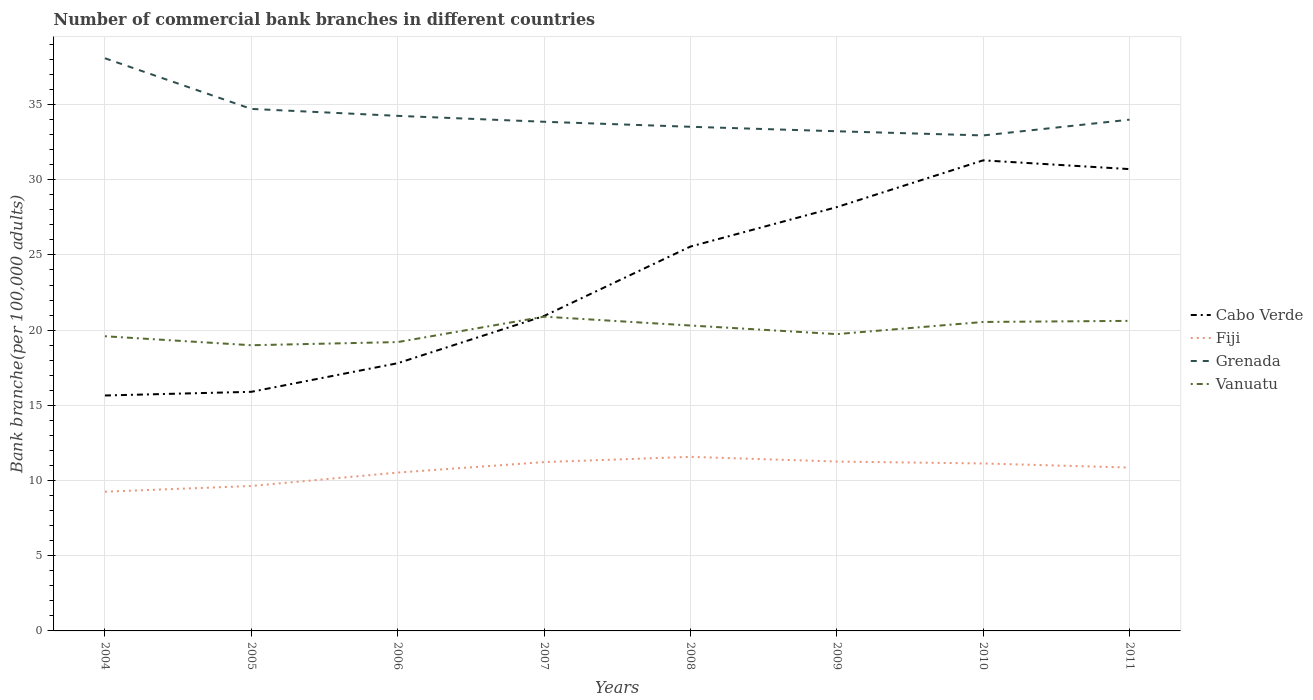How many different coloured lines are there?
Offer a very short reply. 4. Does the line corresponding to Grenada intersect with the line corresponding to Fiji?
Provide a short and direct response. No. Is the number of lines equal to the number of legend labels?
Provide a short and direct response. Yes. Across all years, what is the maximum number of commercial bank branches in Vanuatu?
Offer a terse response. 19. In which year was the number of commercial bank branches in Vanuatu maximum?
Your answer should be very brief. 2005. What is the total number of commercial bank branches in Cabo Verde in the graph?
Offer a terse response. -12.28. What is the difference between the highest and the second highest number of commercial bank branches in Cabo Verde?
Your response must be concise. 15.63. What is the difference between the highest and the lowest number of commercial bank branches in Fiji?
Keep it short and to the point. 5. Is the number of commercial bank branches in Grenada strictly greater than the number of commercial bank branches in Vanuatu over the years?
Ensure brevity in your answer.  No. How many years are there in the graph?
Provide a short and direct response. 8. Are the values on the major ticks of Y-axis written in scientific E-notation?
Your response must be concise. No. Does the graph contain any zero values?
Ensure brevity in your answer.  No. How many legend labels are there?
Offer a very short reply. 4. How are the legend labels stacked?
Make the answer very short. Vertical. What is the title of the graph?
Keep it short and to the point. Number of commercial bank branches in different countries. What is the label or title of the Y-axis?
Keep it short and to the point. Bank branche(per 100,0 adults). What is the Bank branche(per 100,000 adults) in Cabo Verde in 2004?
Provide a succinct answer. 15.65. What is the Bank branche(per 100,000 adults) in Fiji in 2004?
Your answer should be very brief. 9.26. What is the Bank branche(per 100,000 adults) in Grenada in 2004?
Ensure brevity in your answer.  38.08. What is the Bank branche(per 100,000 adults) of Vanuatu in 2004?
Offer a very short reply. 19.59. What is the Bank branche(per 100,000 adults) in Cabo Verde in 2005?
Offer a terse response. 15.9. What is the Bank branche(per 100,000 adults) in Fiji in 2005?
Offer a terse response. 9.64. What is the Bank branche(per 100,000 adults) in Grenada in 2005?
Your answer should be compact. 34.71. What is the Bank branche(per 100,000 adults) in Vanuatu in 2005?
Provide a short and direct response. 19. What is the Bank branche(per 100,000 adults) of Cabo Verde in 2006?
Give a very brief answer. 17.8. What is the Bank branche(per 100,000 adults) of Fiji in 2006?
Ensure brevity in your answer.  10.53. What is the Bank branche(per 100,000 adults) of Grenada in 2006?
Keep it short and to the point. 34.25. What is the Bank branche(per 100,000 adults) in Vanuatu in 2006?
Offer a very short reply. 19.21. What is the Bank branche(per 100,000 adults) of Cabo Verde in 2007?
Provide a short and direct response. 20.94. What is the Bank branche(per 100,000 adults) of Fiji in 2007?
Offer a terse response. 11.23. What is the Bank branche(per 100,000 adults) in Grenada in 2007?
Offer a very short reply. 33.86. What is the Bank branche(per 100,000 adults) in Vanuatu in 2007?
Your answer should be compact. 20.9. What is the Bank branche(per 100,000 adults) in Cabo Verde in 2008?
Offer a terse response. 25.56. What is the Bank branche(per 100,000 adults) in Fiji in 2008?
Offer a very short reply. 11.57. What is the Bank branche(per 100,000 adults) in Grenada in 2008?
Make the answer very short. 33.52. What is the Bank branche(per 100,000 adults) of Vanuatu in 2008?
Make the answer very short. 20.31. What is the Bank branche(per 100,000 adults) in Cabo Verde in 2009?
Provide a succinct answer. 28.18. What is the Bank branche(per 100,000 adults) of Fiji in 2009?
Provide a succinct answer. 11.26. What is the Bank branche(per 100,000 adults) of Grenada in 2009?
Offer a terse response. 33.22. What is the Bank branche(per 100,000 adults) of Vanuatu in 2009?
Offer a very short reply. 19.74. What is the Bank branche(per 100,000 adults) in Cabo Verde in 2010?
Make the answer very short. 31.29. What is the Bank branche(per 100,000 adults) of Fiji in 2010?
Make the answer very short. 11.14. What is the Bank branche(per 100,000 adults) in Grenada in 2010?
Your response must be concise. 32.95. What is the Bank branche(per 100,000 adults) of Vanuatu in 2010?
Make the answer very short. 20.54. What is the Bank branche(per 100,000 adults) in Cabo Verde in 2011?
Your answer should be very brief. 30.71. What is the Bank branche(per 100,000 adults) of Fiji in 2011?
Provide a succinct answer. 10.86. What is the Bank branche(per 100,000 adults) in Grenada in 2011?
Keep it short and to the point. 34. What is the Bank branche(per 100,000 adults) of Vanuatu in 2011?
Ensure brevity in your answer.  20.62. Across all years, what is the maximum Bank branche(per 100,000 adults) in Cabo Verde?
Make the answer very short. 31.29. Across all years, what is the maximum Bank branche(per 100,000 adults) in Fiji?
Provide a short and direct response. 11.57. Across all years, what is the maximum Bank branche(per 100,000 adults) of Grenada?
Your response must be concise. 38.08. Across all years, what is the maximum Bank branche(per 100,000 adults) of Vanuatu?
Ensure brevity in your answer.  20.9. Across all years, what is the minimum Bank branche(per 100,000 adults) in Cabo Verde?
Your answer should be very brief. 15.65. Across all years, what is the minimum Bank branche(per 100,000 adults) of Fiji?
Your response must be concise. 9.26. Across all years, what is the minimum Bank branche(per 100,000 adults) of Grenada?
Provide a succinct answer. 32.95. Across all years, what is the minimum Bank branche(per 100,000 adults) in Vanuatu?
Provide a succinct answer. 19. What is the total Bank branche(per 100,000 adults) of Cabo Verde in the graph?
Ensure brevity in your answer.  186.03. What is the total Bank branche(per 100,000 adults) in Fiji in the graph?
Your answer should be compact. 85.48. What is the total Bank branche(per 100,000 adults) in Grenada in the graph?
Ensure brevity in your answer.  274.58. What is the total Bank branche(per 100,000 adults) in Vanuatu in the graph?
Offer a terse response. 159.9. What is the difference between the Bank branche(per 100,000 adults) of Cabo Verde in 2004 and that in 2005?
Offer a very short reply. -0.24. What is the difference between the Bank branche(per 100,000 adults) of Fiji in 2004 and that in 2005?
Your answer should be very brief. -0.38. What is the difference between the Bank branche(per 100,000 adults) in Grenada in 2004 and that in 2005?
Provide a short and direct response. 3.37. What is the difference between the Bank branche(per 100,000 adults) in Vanuatu in 2004 and that in 2005?
Offer a terse response. 0.6. What is the difference between the Bank branche(per 100,000 adults) in Cabo Verde in 2004 and that in 2006?
Ensure brevity in your answer.  -2.15. What is the difference between the Bank branche(per 100,000 adults) of Fiji in 2004 and that in 2006?
Make the answer very short. -1.27. What is the difference between the Bank branche(per 100,000 adults) of Grenada in 2004 and that in 2006?
Ensure brevity in your answer.  3.83. What is the difference between the Bank branche(per 100,000 adults) of Vanuatu in 2004 and that in 2006?
Your response must be concise. 0.39. What is the difference between the Bank branche(per 100,000 adults) of Cabo Verde in 2004 and that in 2007?
Keep it short and to the point. -5.29. What is the difference between the Bank branche(per 100,000 adults) of Fiji in 2004 and that in 2007?
Give a very brief answer. -1.97. What is the difference between the Bank branche(per 100,000 adults) in Grenada in 2004 and that in 2007?
Offer a very short reply. 4.22. What is the difference between the Bank branche(per 100,000 adults) of Vanuatu in 2004 and that in 2007?
Make the answer very short. -1.3. What is the difference between the Bank branche(per 100,000 adults) of Cabo Verde in 2004 and that in 2008?
Ensure brevity in your answer.  -9.9. What is the difference between the Bank branche(per 100,000 adults) in Fiji in 2004 and that in 2008?
Make the answer very short. -2.32. What is the difference between the Bank branche(per 100,000 adults) of Grenada in 2004 and that in 2008?
Offer a terse response. 4.56. What is the difference between the Bank branche(per 100,000 adults) in Vanuatu in 2004 and that in 2008?
Give a very brief answer. -0.71. What is the difference between the Bank branche(per 100,000 adults) in Cabo Verde in 2004 and that in 2009?
Offer a very short reply. -12.53. What is the difference between the Bank branche(per 100,000 adults) of Fiji in 2004 and that in 2009?
Give a very brief answer. -2.01. What is the difference between the Bank branche(per 100,000 adults) of Grenada in 2004 and that in 2009?
Your answer should be compact. 4.85. What is the difference between the Bank branche(per 100,000 adults) of Vanuatu in 2004 and that in 2009?
Your answer should be very brief. -0.14. What is the difference between the Bank branche(per 100,000 adults) of Cabo Verde in 2004 and that in 2010?
Offer a terse response. -15.63. What is the difference between the Bank branche(per 100,000 adults) in Fiji in 2004 and that in 2010?
Ensure brevity in your answer.  -1.88. What is the difference between the Bank branche(per 100,000 adults) of Grenada in 2004 and that in 2010?
Offer a very short reply. 5.13. What is the difference between the Bank branche(per 100,000 adults) in Vanuatu in 2004 and that in 2010?
Offer a very short reply. -0.95. What is the difference between the Bank branche(per 100,000 adults) of Cabo Verde in 2004 and that in 2011?
Your response must be concise. -15.05. What is the difference between the Bank branche(per 100,000 adults) in Fiji in 2004 and that in 2011?
Provide a short and direct response. -1.61. What is the difference between the Bank branche(per 100,000 adults) of Grenada in 2004 and that in 2011?
Your response must be concise. 4.08. What is the difference between the Bank branche(per 100,000 adults) of Vanuatu in 2004 and that in 2011?
Your answer should be compact. -1.02. What is the difference between the Bank branche(per 100,000 adults) of Cabo Verde in 2005 and that in 2006?
Keep it short and to the point. -1.9. What is the difference between the Bank branche(per 100,000 adults) of Fiji in 2005 and that in 2006?
Ensure brevity in your answer.  -0.89. What is the difference between the Bank branche(per 100,000 adults) in Grenada in 2005 and that in 2006?
Give a very brief answer. 0.46. What is the difference between the Bank branche(per 100,000 adults) of Vanuatu in 2005 and that in 2006?
Offer a terse response. -0.21. What is the difference between the Bank branche(per 100,000 adults) of Cabo Verde in 2005 and that in 2007?
Provide a succinct answer. -5.04. What is the difference between the Bank branche(per 100,000 adults) of Fiji in 2005 and that in 2007?
Offer a terse response. -1.59. What is the difference between the Bank branche(per 100,000 adults) in Grenada in 2005 and that in 2007?
Make the answer very short. 0.85. What is the difference between the Bank branche(per 100,000 adults) in Vanuatu in 2005 and that in 2007?
Offer a terse response. -1.9. What is the difference between the Bank branche(per 100,000 adults) of Cabo Verde in 2005 and that in 2008?
Make the answer very short. -9.66. What is the difference between the Bank branche(per 100,000 adults) in Fiji in 2005 and that in 2008?
Ensure brevity in your answer.  -1.94. What is the difference between the Bank branche(per 100,000 adults) of Grenada in 2005 and that in 2008?
Give a very brief answer. 1.19. What is the difference between the Bank branche(per 100,000 adults) of Vanuatu in 2005 and that in 2008?
Make the answer very short. -1.31. What is the difference between the Bank branche(per 100,000 adults) of Cabo Verde in 2005 and that in 2009?
Your answer should be very brief. -12.28. What is the difference between the Bank branche(per 100,000 adults) in Fiji in 2005 and that in 2009?
Your answer should be compact. -1.62. What is the difference between the Bank branche(per 100,000 adults) of Grenada in 2005 and that in 2009?
Your answer should be very brief. 1.49. What is the difference between the Bank branche(per 100,000 adults) in Vanuatu in 2005 and that in 2009?
Your answer should be very brief. -0.74. What is the difference between the Bank branche(per 100,000 adults) of Cabo Verde in 2005 and that in 2010?
Offer a very short reply. -15.39. What is the difference between the Bank branche(per 100,000 adults) in Fiji in 2005 and that in 2010?
Your answer should be very brief. -1.5. What is the difference between the Bank branche(per 100,000 adults) of Grenada in 2005 and that in 2010?
Offer a terse response. 1.76. What is the difference between the Bank branche(per 100,000 adults) of Vanuatu in 2005 and that in 2010?
Provide a succinct answer. -1.55. What is the difference between the Bank branche(per 100,000 adults) of Cabo Verde in 2005 and that in 2011?
Give a very brief answer. -14.81. What is the difference between the Bank branche(per 100,000 adults) of Fiji in 2005 and that in 2011?
Your answer should be very brief. -1.22. What is the difference between the Bank branche(per 100,000 adults) in Grenada in 2005 and that in 2011?
Make the answer very short. 0.71. What is the difference between the Bank branche(per 100,000 adults) of Vanuatu in 2005 and that in 2011?
Your answer should be very brief. -1.62. What is the difference between the Bank branche(per 100,000 adults) in Cabo Verde in 2006 and that in 2007?
Keep it short and to the point. -3.14. What is the difference between the Bank branche(per 100,000 adults) of Fiji in 2006 and that in 2007?
Your answer should be compact. -0.7. What is the difference between the Bank branche(per 100,000 adults) of Grenada in 2006 and that in 2007?
Keep it short and to the point. 0.39. What is the difference between the Bank branche(per 100,000 adults) in Vanuatu in 2006 and that in 2007?
Offer a terse response. -1.69. What is the difference between the Bank branche(per 100,000 adults) in Cabo Verde in 2006 and that in 2008?
Offer a very short reply. -7.76. What is the difference between the Bank branche(per 100,000 adults) in Fiji in 2006 and that in 2008?
Provide a short and direct response. -1.05. What is the difference between the Bank branche(per 100,000 adults) of Grenada in 2006 and that in 2008?
Your response must be concise. 0.73. What is the difference between the Bank branche(per 100,000 adults) of Vanuatu in 2006 and that in 2008?
Your response must be concise. -1.1. What is the difference between the Bank branche(per 100,000 adults) of Cabo Verde in 2006 and that in 2009?
Provide a succinct answer. -10.38. What is the difference between the Bank branche(per 100,000 adults) in Fiji in 2006 and that in 2009?
Ensure brevity in your answer.  -0.73. What is the difference between the Bank branche(per 100,000 adults) in Grenada in 2006 and that in 2009?
Your answer should be very brief. 1.02. What is the difference between the Bank branche(per 100,000 adults) of Vanuatu in 2006 and that in 2009?
Provide a short and direct response. -0.53. What is the difference between the Bank branche(per 100,000 adults) in Cabo Verde in 2006 and that in 2010?
Provide a short and direct response. -13.49. What is the difference between the Bank branche(per 100,000 adults) in Fiji in 2006 and that in 2010?
Keep it short and to the point. -0.61. What is the difference between the Bank branche(per 100,000 adults) of Grenada in 2006 and that in 2010?
Offer a terse response. 1.3. What is the difference between the Bank branche(per 100,000 adults) of Vanuatu in 2006 and that in 2010?
Your response must be concise. -1.34. What is the difference between the Bank branche(per 100,000 adults) in Cabo Verde in 2006 and that in 2011?
Give a very brief answer. -12.91. What is the difference between the Bank branche(per 100,000 adults) of Fiji in 2006 and that in 2011?
Ensure brevity in your answer.  -0.33. What is the difference between the Bank branche(per 100,000 adults) in Grenada in 2006 and that in 2011?
Your response must be concise. 0.25. What is the difference between the Bank branche(per 100,000 adults) in Vanuatu in 2006 and that in 2011?
Offer a terse response. -1.41. What is the difference between the Bank branche(per 100,000 adults) in Cabo Verde in 2007 and that in 2008?
Provide a short and direct response. -4.62. What is the difference between the Bank branche(per 100,000 adults) in Fiji in 2007 and that in 2008?
Give a very brief answer. -0.35. What is the difference between the Bank branche(per 100,000 adults) of Grenada in 2007 and that in 2008?
Give a very brief answer. 0.33. What is the difference between the Bank branche(per 100,000 adults) of Vanuatu in 2007 and that in 2008?
Make the answer very short. 0.59. What is the difference between the Bank branche(per 100,000 adults) in Cabo Verde in 2007 and that in 2009?
Keep it short and to the point. -7.24. What is the difference between the Bank branche(per 100,000 adults) of Fiji in 2007 and that in 2009?
Provide a succinct answer. -0.04. What is the difference between the Bank branche(per 100,000 adults) of Grenada in 2007 and that in 2009?
Provide a short and direct response. 0.63. What is the difference between the Bank branche(per 100,000 adults) in Vanuatu in 2007 and that in 2009?
Your answer should be very brief. 1.16. What is the difference between the Bank branche(per 100,000 adults) of Cabo Verde in 2007 and that in 2010?
Offer a very short reply. -10.35. What is the difference between the Bank branche(per 100,000 adults) in Fiji in 2007 and that in 2010?
Make the answer very short. 0.09. What is the difference between the Bank branche(per 100,000 adults) in Grenada in 2007 and that in 2010?
Your answer should be compact. 0.91. What is the difference between the Bank branche(per 100,000 adults) in Vanuatu in 2007 and that in 2010?
Your answer should be very brief. 0.35. What is the difference between the Bank branche(per 100,000 adults) of Cabo Verde in 2007 and that in 2011?
Keep it short and to the point. -9.77. What is the difference between the Bank branche(per 100,000 adults) of Fiji in 2007 and that in 2011?
Give a very brief answer. 0.36. What is the difference between the Bank branche(per 100,000 adults) in Grenada in 2007 and that in 2011?
Give a very brief answer. -0.14. What is the difference between the Bank branche(per 100,000 adults) of Vanuatu in 2007 and that in 2011?
Your response must be concise. 0.28. What is the difference between the Bank branche(per 100,000 adults) of Cabo Verde in 2008 and that in 2009?
Your response must be concise. -2.62. What is the difference between the Bank branche(per 100,000 adults) of Fiji in 2008 and that in 2009?
Your answer should be compact. 0.31. What is the difference between the Bank branche(per 100,000 adults) of Grenada in 2008 and that in 2009?
Provide a short and direct response. 0.3. What is the difference between the Bank branche(per 100,000 adults) of Vanuatu in 2008 and that in 2009?
Ensure brevity in your answer.  0.57. What is the difference between the Bank branche(per 100,000 adults) of Cabo Verde in 2008 and that in 2010?
Provide a succinct answer. -5.73. What is the difference between the Bank branche(per 100,000 adults) in Fiji in 2008 and that in 2010?
Your answer should be very brief. 0.44. What is the difference between the Bank branche(per 100,000 adults) of Grenada in 2008 and that in 2010?
Provide a succinct answer. 0.58. What is the difference between the Bank branche(per 100,000 adults) in Vanuatu in 2008 and that in 2010?
Provide a succinct answer. -0.24. What is the difference between the Bank branche(per 100,000 adults) of Cabo Verde in 2008 and that in 2011?
Ensure brevity in your answer.  -5.15. What is the difference between the Bank branche(per 100,000 adults) of Fiji in 2008 and that in 2011?
Keep it short and to the point. 0.71. What is the difference between the Bank branche(per 100,000 adults) in Grenada in 2008 and that in 2011?
Provide a short and direct response. -0.47. What is the difference between the Bank branche(per 100,000 adults) in Vanuatu in 2008 and that in 2011?
Your response must be concise. -0.31. What is the difference between the Bank branche(per 100,000 adults) of Cabo Verde in 2009 and that in 2010?
Provide a short and direct response. -3.11. What is the difference between the Bank branche(per 100,000 adults) in Fiji in 2009 and that in 2010?
Provide a succinct answer. 0.13. What is the difference between the Bank branche(per 100,000 adults) of Grenada in 2009 and that in 2010?
Offer a terse response. 0.28. What is the difference between the Bank branche(per 100,000 adults) of Vanuatu in 2009 and that in 2010?
Give a very brief answer. -0.81. What is the difference between the Bank branche(per 100,000 adults) in Cabo Verde in 2009 and that in 2011?
Give a very brief answer. -2.53. What is the difference between the Bank branche(per 100,000 adults) in Fiji in 2009 and that in 2011?
Provide a succinct answer. 0.4. What is the difference between the Bank branche(per 100,000 adults) in Grenada in 2009 and that in 2011?
Ensure brevity in your answer.  -0.77. What is the difference between the Bank branche(per 100,000 adults) of Vanuatu in 2009 and that in 2011?
Your answer should be very brief. -0.88. What is the difference between the Bank branche(per 100,000 adults) in Cabo Verde in 2010 and that in 2011?
Your answer should be very brief. 0.58. What is the difference between the Bank branche(per 100,000 adults) in Fiji in 2010 and that in 2011?
Ensure brevity in your answer.  0.27. What is the difference between the Bank branche(per 100,000 adults) of Grenada in 2010 and that in 2011?
Ensure brevity in your answer.  -1.05. What is the difference between the Bank branche(per 100,000 adults) in Vanuatu in 2010 and that in 2011?
Your answer should be compact. -0.07. What is the difference between the Bank branche(per 100,000 adults) in Cabo Verde in 2004 and the Bank branche(per 100,000 adults) in Fiji in 2005?
Provide a succinct answer. 6.02. What is the difference between the Bank branche(per 100,000 adults) in Cabo Verde in 2004 and the Bank branche(per 100,000 adults) in Grenada in 2005?
Provide a succinct answer. -19.06. What is the difference between the Bank branche(per 100,000 adults) of Cabo Verde in 2004 and the Bank branche(per 100,000 adults) of Vanuatu in 2005?
Offer a very short reply. -3.34. What is the difference between the Bank branche(per 100,000 adults) of Fiji in 2004 and the Bank branche(per 100,000 adults) of Grenada in 2005?
Offer a terse response. -25.45. What is the difference between the Bank branche(per 100,000 adults) in Fiji in 2004 and the Bank branche(per 100,000 adults) in Vanuatu in 2005?
Ensure brevity in your answer.  -9.74. What is the difference between the Bank branche(per 100,000 adults) in Grenada in 2004 and the Bank branche(per 100,000 adults) in Vanuatu in 2005?
Your response must be concise. 19.08. What is the difference between the Bank branche(per 100,000 adults) in Cabo Verde in 2004 and the Bank branche(per 100,000 adults) in Fiji in 2006?
Your answer should be very brief. 5.13. What is the difference between the Bank branche(per 100,000 adults) of Cabo Verde in 2004 and the Bank branche(per 100,000 adults) of Grenada in 2006?
Your answer should be compact. -18.59. What is the difference between the Bank branche(per 100,000 adults) of Cabo Verde in 2004 and the Bank branche(per 100,000 adults) of Vanuatu in 2006?
Offer a terse response. -3.55. What is the difference between the Bank branche(per 100,000 adults) of Fiji in 2004 and the Bank branche(per 100,000 adults) of Grenada in 2006?
Provide a succinct answer. -24.99. What is the difference between the Bank branche(per 100,000 adults) in Fiji in 2004 and the Bank branche(per 100,000 adults) in Vanuatu in 2006?
Ensure brevity in your answer.  -9.95. What is the difference between the Bank branche(per 100,000 adults) in Grenada in 2004 and the Bank branche(per 100,000 adults) in Vanuatu in 2006?
Offer a terse response. 18.87. What is the difference between the Bank branche(per 100,000 adults) of Cabo Verde in 2004 and the Bank branche(per 100,000 adults) of Fiji in 2007?
Offer a terse response. 4.43. What is the difference between the Bank branche(per 100,000 adults) of Cabo Verde in 2004 and the Bank branche(per 100,000 adults) of Grenada in 2007?
Your answer should be compact. -18.2. What is the difference between the Bank branche(per 100,000 adults) in Cabo Verde in 2004 and the Bank branche(per 100,000 adults) in Vanuatu in 2007?
Your response must be concise. -5.24. What is the difference between the Bank branche(per 100,000 adults) in Fiji in 2004 and the Bank branche(per 100,000 adults) in Grenada in 2007?
Provide a short and direct response. -24.6. What is the difference between the Bank branche(per 100,000 adults) of Fiji in 2004 and the Bank branche(per 100,000 adults) of Vanuatu in 2007?
Provide a short and direct response. -11.64. What is the difference between the Bank branche(per 100,000 adults) of Grenada in 2004 and the Bank branche(per 100,000 adults) of Vanuatu in 2007?
Offer a very short reply. 17.18. What is the difference between the Bank branche(per 100,000 adults) in Cabo Verde in 2004 and the Bank branche(per 100,000 adults) in Fiji in 2008?
Keep it short and to the point. 4.08. What is the difference between the Bank branche(per 100,000 adults) in Cabo Verde in 2004 and the Bank branche(per 100,000 adults) in Grenada in 2008?
Keep it short and to the point. -17.87. What is the difference between the Bank branche(per 100,000 adults) of Cabo Verde in 2004 and the Bank branche(per 100,000 adults) of Vanuatu in 2008?
Offer a terse response. -4.65. What is the difference between the Bank branche(per 100,000 adults) of Fiji in 2004 and the Bank branche(per 100,000 adults) of Grenada in 2008?
Ensure brevity in your answer.  -24.27. What is the difference between the Bank branche(per 100,000 adults) of Fiji in 2004 and the Bank branche(per 100,000 adults) of Vanuatu in 2008?
Offer a very short reply. -11.05. What is the difference between the Bank branche(per 100,000 adults) of Grenada in 2004 and the Bank branche(per 100,000 adults) of Vanuatu in 2008?
Your answer should be compact. 17.77. What is the difference between the Bank branche(per 100,000 adults) in Cabo Verde in 2004 and the Bank branche(per 100,000 adults) in Fiji in 2009?
Ensure brevity in your answer.  4.39. What is the difference between the Bank branche(per 100,000 adults) of Cabo Verde in 2004 and the Bank branche(per 100,000 adults) of Grenada in 2009?
Give a very brief answer. -17.57. What is the difference between the Bank branche(per 100,000 adults) in Cabo Verde in 2004 and the Bank branche(per 100,000 adults) in Vanuatu in 2009?
Your answer should be very brief. -4.08. What is the difference between the Bank branche(per 100,000 adults) in Fiji in 2004 and the Bank branche(per 100,000 adults) in Grenada in 2009?
Your answer should be compact. -23.97. What is the difference between the Bank branche(per 100,000 adults) of Fiji in 2004 and the Bank branche(per 100,000 adults) of Vanuatu in 2009?
Make the answer very short. -10.48. What is the difference between the Bank branche(per 100,000 adults) of Grenada in 2004 and the Bank branche(per 100,000 adults) of Vanuatu in 2009?
Provide a short and direct response. 18.34. What is the difference between the Bank branche(per 100,000 adults) of Cabo Verde in 2004 and the Bank branche(per 100,000 adults) of Fiji in 2010?
Keep it short and to the point. 4.52. What is the difference between the Bank branche(per 100,000 adults) in Cabo Verde in 2004 and the Bank branche(per 100,000 adults) in Grenada in 2010?
Your response must be concise. -17.29. What is the difference between the Bank branche(per 100,000 adults) in Cabo Verde in 2004 and the Bank branche(per 100,000 adults) in Vanuatu in 2010?
Provide a short and direct response. -4.89. What is the difference between the Bank branche(per 100,000 adults) in Fiji in 2004 and the Bank branche(per 100,000 adults) in Grenada in 2010?
Your answer should be compact. -23.69. What is the difference between the Bank branche(per 100,000 adults) of Fiji in 2004 and the Bank branche(per 100,000 adults) of Vanuatu in 2010?
Offer a very short reply. -11.29. What is the difference between the Bank branche(per 100,000 adults) of Grenada in 2004 and the Bank branche(per 100,000 adults) of Vanuatu in 2010?
Provide a succinct answer. 17.54. What is the difference between the Bank branche(per 100,000 adults) in Cabo Verde in 2004 and the Bank branche(per 100,000 adults) in Fiji in 2011?
Keep it short and to the point. 4.79. What is the difference between the Bank branche(per 100,000 adults) of Cabo Verde in 2004 and the Bank branche(per 100,000 adults) of Grenada in 2011?
Keep it short and to the point. -18.34. What is the difference between the Bank branche(per 100,000 adults) in Cabo Verde in 2004 and the Bank branche(per 100,000 adults) in Vanuatu in 2011?
Keep it short and to the point. -4.96. What is the difference between the Bank branche(per 100,000 adults) in Fiji in 2004 and the Bank branche(per 100,000 adults) in Grenada in 2011?
Your answer should be very brief. -24.74. What is the difference between the Bank branche(per 100,000 adults) in Fiji in 2004 and the Bank branche(per 100,000 adults) in Vanuatu in 2011?
Your answer should be very brief. -11.36. What is the difference between the Bank branche(per 100,000 adults) in Grenada in 2004 and the Bank branche(per 100,000 adults) in Vanuatu in 2011?
Your answer should be very brief. 17.46. What is the difference between the Bank branche(per 100,000 adults) in Cabo Verde in 2005 and the Bank branche(per 100,000 adults) in Fiji in 2006?
Your response must be concise. 5.37. What is the difference between the Bank branche(per 100,000 adults) of Cabo Verde in 2005 and the Bank branche(per 100,000 adults) of Grenada in 2006?
Your answer should be very brief. -18.35. What is the difference between the Bank branche(per 100,000 adults) of Cabo Verde in 2005 and the Bank branche(per 100,000 adults) of Vanuatu in 2006?
Provide a short and direct response. -3.31. What is the difference between the Bank branche(per 100,000 adults) in Fiji in 2005 and the Bank branche(per 100,000 adults) in Grenada in 2006?
Give a very brief answer. -24.61. What is the difference between the Bank branche(per 100,000 adults) in Fiji in 2005 and the Bank branche(per 100,000 adults) in Vanuatu in 2006?
Your answer should be very brief. -9.57. What is the difference between the Bank branche(per 100,000 adults) in Grenada in 2005 and the Bank branche(per 100,000 adults) in Vanuatu in 2006?
Make the answer very short. 15.5. What is the difference between the Bank branche(per 100,000 adults) of Cabo Verde in 2005 and the Bank branche(per 100,000 adults) of Fiji in 2007?
Give a very brief answer. 4.67. What is the difference between the Bank branche(per 100,000 adults) in Cabo Verde in 2005 and the Bank branche(per 100,000 adults) in Grenada in 2007?
Your response must be concise. -17.96. What is the difference between the Bank branche(per 100,000 adults) in Cabo Verde in 2005 and the Bank branche(per 100,000 adults) in Vanuatu in 2007?
Ensure brevity in your answer.  -5. What is the difference between the Bank branche(per 100,000 adults) in Fiji in 2005 and the Bank branche(per 100,000 adults) in Grenada in 2007?
Ensure brevity in your answer.  -24.22. What is the difference between the Bank branche(per 100,000 adults) of Fiji in 2005 and the Bank branche(per 100,000 adults) of Vanuatu in 2007?
Give a very brief answer. -11.26. What is the difference between the Bank branche(per 100,000 adults) of Grenada in 2005 and the Bank branche(per 100,000 adults) of Vanuatu in 2007?
Provide a short and direct response. 13.81. What is the difference between the Bank branche(per 100,000 adults) in Cabo Verde in 2005 and the Bank branche(per 100,000 adults) in Fiji in 2008?
Give a very brief answer. 4.32. What is the difference between the Bank branche(per 100,000 adults) of Cabo Verde in 2005 and the Bank branche(per 100,000 adults) of Grenada in 2008?
Ensure brevity in your answer.  -17.62. What is the difference between the Bank branche(per 100,000 adults) of Cabo Verde in 2005 and the Bank branche(per 100,000 adults) of Vanuatu in 2008?
Make the answer very short. -4.41. What is the difference between the Bank branche(per 100,000 adults) in Fiji in 2005 and the Bank branche(per 100,000 adults) in Grenada in 2008?
Provide a short and direct response. -23.88. What is the difference between the Bank branche(per 100,000 adults) in Fiji in 2005 and the Bank branche(per 100,000 adults) in Vanuatu in 2008?
Offer a terse response. -10.67. What is the difference between the Bank branche(per 100,000 adults) of Grenada in 2005 and the Bank branche(per 100,000 adults) of Vanuatu in 2008?
Make the answer very short. 14.4. What is the difference between the Bank branche(per 100,000 adults) in Cabo Verde in 2005 and the Bank branche(per 100,000 adults) in Fiji in 2009?
Offer a very short reply. 4.64. What is the difference between the Bank branche(per 100,000 adults) of Cabo Verde in 2005 and the Bank branche(per 100,000 adults) of Grenada in 2009?
Provide a short and direct response. -17.32. What is the difference between the Bank branche(per 100,000 adults) in Cabo Verde in 2005 and the Bank branche(per 100,000 adults) in Vanuatu in 2009?
Offer a very short reply. -3.84. What is the difference between the Bank branche(per 100,000 adults) in Fiji in 2005 and the Bank branche(per 100,000 adults) in Grenada in 2009?
Give a very brief answer. -23.59. What is the difference between the Bank branche(per 100,000 adults) in Fiji in 2005 and the Bank branche(per 100,000 adults) in Vanuatu in 2009?
Provide a short and direct response. -10.1. What is the difference between the Bank branche(per 100,000 adults) in Grenada in 2005 and the Bank branche(per 100,000 adults) in Vanuatu in 2009?
Offer a very short reply. 14.97. What is the difference between the Bank branche(per 100,000 adults) of Cabo Verde in 2005 and the Bank branche(per 100,000 adults) of Fiji in 2010?
Give a very brief answer. 4.76. What is the difference between the Bank branche(per 100,000 adults) of Cabo Verde in 2005 and the Bank branche(per 100,000 adults) of Grenada in 2010?
Provide a succinct answer. -17.05. What is the difference between the Bank branche(per 100,000 adults) of Cabo Verde in 2005 and the Bank branche(per 100,000 adults) of Vanuatu in 2010?
Offer a terse response. -4.64. What is the difference between the Bank branche(per 100,000 adults) in Fiji in 2005 and the Bank branche(per 100,000 adults) in Grenada in 2010?
Your answer should be compact. -23.31. What is the difference between the Bank branche(per 100,000 adults) of Fiji in 2005 and the Bank branche(per 100,000 adults) of Vanuatu in 2010?
Offer a terse response. -10.91. What is the difference between the Bank branche(per 100,000 adults) of Grenada in 2005 and the Bank branche(per 100,000 adults) of Vanuatu in 2010?
Ensure brevity in your answer.  14.17. What is the difference between the Bank branche(per 100,000 adults) in Cabo Verde in 2005 and the Bank branche(per 100,000 adults) in Fiji in 2011?
Make the answer very short. 5.04. What is the difference between the Bank branche(per 100,000 adults) in Cabo Verde in 2005 and the Bank branche(per 100,000 adults) in Grenada in 2011?
Your answer should be very brief. -18.1. What is the difference between the Bank branche(per 100,000 adults) in Cabo Verde in 2005 and the Bank branche(per 100,000 adults) in Vanuatu in 2011?
Keep it short and to the point. -4.72. What is the difference between the Bank branche(per 100,000 adults) in Fiji in 2005 and the Bank branche(per 100,000 adults) in Grenada in 2011?
Your response must be concise. -24.36. What is the difference between the Bank branche(per 100,000 adults) in Fiji in 2005 and the Bank branche(per 100,000 adults) in Vanuatu in 2011?
Your answer should be very brief. -10.98. What is the difference between the Bank branche(per 100,000 adults) in Grenada in 2005 and the Bank branche(per 100,000 adults) in Vanuatu in 2011?
Make the answer very short. 14.09. What is the difference between the Bank branche(per 100,000 adults) of Cabo Verde in 2006 and the Bank branche(per 100,000 adults) of Fiji in 2007?
Your answer should be compact. 6.58. What is the difference between the Bank branche(per 100,000 adults) of Cabo Verde in 2006 and the Bank branche(per 100,000 adults) of Grenada in 2007?
Your answer should be compact. -16.05. What is the difference between the Bank branche(per 100,000 adults) in Cabo Verde in 2006 and the Bank branche(per 100,000 adults) in Vanuatu in 2007?
Your answer should be very brief. -3.09. What is the difference between the Bank branche(per 100,000 adults) in Fiji in 2006 and the Bank branche(per 100,000 adults) in Grenada in 2007?
Your answer should be very brief. -23.33. What is the difference between the Bank branche(per 100,000 adults) in Fiji in 2006 and the Bank branche(per 100,000 adults) in Vanuatu in 2007?
Your answer should be very brief. -10.37. What is the difference between the Bank branche(per 100,000 adults) in Grenada in 2006 and the Bank branche(per 100,000 adults) in Vanuatu in 2007?
Give a very brief answer. 13.35. What is the difference between the Bank branche(per 100,000 adults) in Cabo Verde in 2006 and the Bank branche(per 100,000 adults) in Fiji in 2008?
Offer a very short reply. 6.23. What is the difference between the Bank branche(per 100,000 adults) of Cabo Verde in 2006 and the Bank branche(per 100,000 adults) of Grenada in 2008?
Your answer should be compact. -15.72. What is the difference between the Bank branche(per 100,000 adults) of Cabo Verde in 2006 and the Bank branche(per 100,000 adults) of Vanuatu in 2008?
Your answer should be very brief. -2.51. What is the difference between the Bank branche(per 100,000 adults) in Fiji in 2006 and the Bank branche(per 100,000 adults) in Grenada in 2008?
Offer a very short reply. -22.99. What is the difference between the Bank branche(per 100,000 adults) of Fiji in 2006 and the Bank branche(per 100,000 adults) of Vanuatu in 2008?
Keep it short and to the point. -9.78. What is the difference between the Bank branche(per 100,000 adults) of Grenada in 2006 and the Bank branche(per 100,000 adults) of Vanuatu in 2008?
Your answer should be very brief. 13.94. What is the difference between the Bank branche(per 100,000 adults) of Cabo Verde in 2006 and the Bank branche(per 100,000 adults) of Fiji in 2009?
Offer a terse response. 6.54. What is the difference between the Bank branche(per 100,000 adults) of Cabo Verde in 2006 and the Bank branche(per 100,000 adults) of Grenada in 2009?
Offer a terse response. -15.42. What is the difference between the Bank branche(per 100,000 adults) of Cabo Verde in 2006 and the Bank branche(per 100,000 adults) of Vanuatu in 2009?
Your answer should be compact. -1.93. What is the difference between the Bank branche(per 100,000 adults) of Fiji in 2006 and the Bank branche(per 100,000 adults) of Grenada in 2009?
Give a very brief answer. -22.7. What is the difference between the Bank branche(per 100,000 adults) in Fiji in 2006 and the Bank branche(per 100,000 adults) in Vanuatu in 2009?
Your answer should be very brief. -9.21. What is the difference between the Bank branche(per 100,000 adults) in Grenada in 2006 and the Bank branche(per 100,000 adults) in Vanuatu in 2009?
Keep it short and to the point. 14.51. What is the difference between the Bank branche(per 100,000 adults) in Cabo Verde in 2006 and the Bank branche(per 100,000 adults) in Fiji in 2010?
Offer a terse response. 6.67. What is the difference between the Bank branche(per 100,000 adults) of Cabo Verde in 2006 and the Bank branche(per 100,000 adults) of Grenada in 2010?
Give a very brief answer. -15.15. What is the difference between the Bank branche(per 100,000 adults) of Cabo Verde in 2006 and the Bank branche(per 100,000 adults) of Vanuatu in 2010?
Provide a short and direct response. -2.74. What is the difference between the Bank branche(per 100,000 adults) in Fiji in 2006 and the Bank branche(per 100,000 adults) in Grenada in 2010?
Keep it short and to the point. -22.42. What is the difference between the Bank branche(per 100,000 adults) in Fiji in 2006 and the Bank branche(per 100,000 adults) in Vanuatu in 2010?
Offer a terse response. -10.01. What is the difference between the Bank branche(per 100,000 adults) in Grenada in 2006 and the Bank branche(per 100,000 adults) in Vanuatu in 2010?
Provide a succinct answer. 13.71. What is the difference between the Bank branche(per 100,000 adults) in Cabo Verde in 2006 and the Bank branche(per 100,000 adults) in Fiji in 2011?
Give a very brief answer. 6.94. What is the difference between the Bank branche(per 100,000 adults) in Cabo Verde in 2006 and the Bank branche(per 100,000 adults) in Grenada in 2011?
Your answer should be compact. -16.19. What is the difference between the Bank branche(per 100,000 adults) in Cabo Verde in 2006 and the Bank branche(per 100,000 adults) in Vanuatu in 2011?
Your answer should be very brief. -2.81. What is the difference between the Bank branche(per 100,000 adults) in Fiji in 2006 and the Bank branche(per 100,000 adults) in Grenada in 2011?
Make the answer very short. -23.47. What is the difference between the Bank branche(per 100,000 adults) of Fiji in 2006 and the Bank branche(per 100,000 adults) of Vanuatu in 2011?
Offer a very short reply. -10.09. What is the difference between the Bank branche(per 100,000 adults) in Grenada in 2006 and the Bank branche(per 100,000 adults) in Vanuatu in 2011?
Keep it short and to the point. 13.63. What is the difference between the Bank branche(per 100,000 adults) in Cabo Verde in 2007 and the Bank branche(per 100,000 adults) in Fiji in 2008?
Your answer should be very brief. 9.37. What is the difference between the Bank branche(per 100,000 adults) of Cabo Verde in 2007 and the Bank branche(per 100,000 adults) of Grenada in 2008?
Offer a terse response. -12.58. What is the difference between the Bank branche(per 100,000 adults) of Cabo Verde in 2007 and the Bank branche(per 100,000 adults) of Vanuatu in 2008?
Offer a terse response. 0.63. What is the difference between the Bank branche(per 100,000 adults) of Fiji in 2007 and the Bank branche(per 100,000 adults) of Grenada in 2008?
Provide a short and direct response. -22.3. What is the difference between the Bank branche(per 100,000 adults) of Fiji in 2007 and the Bank branche(per 100,000 adults) of Vanuatu in 2008?
Your response must be concise. -9.08. What is the difference between the Bank branche(per 100,000 adults) of Grenada in 2007 and the Bank branche(per 100,000 adults) of Vanuatu in 2008?
Offer a terse response. 13.55. What is the difference between the Bank branche(per 100,000 adults) in Cabo Verde in 2007 and the Bank branche(per 100,000 adults) in Fiji in 2009?
Your answer should be compact. 9.68. What is the difference between the Bank branche(per 100,000 adults) in Cabo Verde in 2007 and the Bank branche(per 100,000 adults) in Grenada in 2009?
Offer a terse response. -12.28. What is the difference between the Bank branche(per 100,000 adults) in Cabo Verde in 2007 and the Bank branche(per 100,000 adults) in Vanuatu in 2009?
Your answer should be very brief. 1.2. What is the difference between the Bank branche(per 100,000 adults) in Fiji in 2007 and the Bank branche(per 100,000 adults) in Grenada in 2009?
Keep it short and to the point. -22. What is the difference between the Bank branche(per 100,000 adults) in Fiji in 2007 and the Bank branche(per 100,000 adults) in Vanuatu in 2009?
Your answer should be compact. -8.51. What is the difference between the Bank branche(per 100,000 adults) in Grenada in 2007 and the Bank branche(per 100,000 adults) in Vanuatu in 2009?
Your answer should be compact. 14.12. What is the difference between the Bank branche(per 100,000 adults) in Cabo Verde in 2007 and the Bank branche(per 100,000 adults) in Fiji in 2010?
Ensure brevity in your answer.  9.81. What is the difference between the Bank branche(per 100,000 adults) of Cabo Verde in 2007 and the Bank branche(per 100,000 adults) of Grenada in 2010?
Offer a very short reply. -12.01. What is the difference between the Bank branche(per 100,000 adults) of Cabo Verde in 2007 and the Bank branche(per 100,000 adults) of Vanuatu in 2010?
Ensure brevity in your answer.  0.4. What is the difference between the Bank branche(per 100,000 adults) of Fiji in 2007 and the Bank branche(per 100,000 adults) of Grenada in 2010?
Offer a very short reply. -21.72. What is the difference between the Bank branche(per 100,000 adults) of Fiji in 2007 and the Bank branche(per 100,000 adults) of Vanuatu in 2010?
Provide a succinct answer. -9.32. What is the difference between the Bank branche(per 100,000 adults) of Grenada in 2007 and the Bank branche(per 100,000 adults) of Vanuatu in 2010?
Your answer should be compact. 13.31. What is the difference between the Bank branche(per 100,000 adults) in Cabo Verde in 2007 and the Bank branche(per 100,000 adults) in Fiji in 2011?
Ensure brevity in your answer.  10.08. What is the difference between the Bank branche(per 100,000 adults) in Cabo Verde in 2007 and the Bank branche(per 100,000 adults) in Grenada in 2011?
Make the answer very short. -13.05. What is the difference between the Bank branche(per 100,000 adults) of Cabo Verde in 2007 and the Bank branche(per 100,000 adults) of Vanuatu in 2011?
Make the answer very short. 0.32. What is the difference between the Bank branche(per 100,000 adults) of Fiji in 2007 and the Bank branche(per 100,000 adults) of Grenada in 2011?
Offer a very short reply. -22.77. What is the difference between the Bank branche(per 100,000 adults) of Fiji in 2007 and the Bank branche(per 100,000 adults) of Vanuatu in 2011?
Your answer should be very brief. -9.39. What is the difference between the Bank branche(per 100,000 adults) of Grenada in 2007 and the Bank branche(per 100,000 adults) of Vanuatu in 2011?
Ensure brevity in your answer.  13.24. What is the difference between the Bank branche(per 100,000 adults) in Cabo Verde in 2008 and the Bank branche(per 100,000 adults) in Fiji in 2009?
Offer a very short reply. 14.29. What is the difference between the Bank branche(per 100,000 adults) of Cabo Verde in 2008 and the Bank branche(per 100,000 adults) of Grenada in 2009?
Give a very brief answer. -7.67. What is the difference between the Bank branche(per 100,000 adults) of Cabo Verde in 2008 and the Bank branche(per 100,000 adults) of Vanuatu in 2009?
Make the answer very short. 5.82. What is the difference between the Bank branche(per 100,000 adults) of Fiji in 2008 and the Bank branche(per 100,000 adults) of Grenada in 2009?
Offer a very short reply. -21.65. What is the difference between the Bank branche(per 100,000 adults) of Fiji in 2008 and the Bank branche(per 100,000 adults) of Vanuatu in 2009?
Your answer should be compact. -8.16. What is the difference between the Bank branche(per 100,000 adults) of Grenada in 2008 and the Bank branche(per 100,000 adults) of Vanuatu in 2009?
Your response must be concise. 13.79. What is the difference between the Bank branche(per 100,000 adults) of Cabo Verde in 2008 and the Bank branche(per 100,000 adults) of Fiji in 2010?
Provide a short and direct response. 14.42. What is the difference between the Bank branche(per 100,000 adults) in Cabo Verde in 2008 and the Bank branche(per 100,000 adults) in Grenada in 2010?
Offer a very short reply. -7.39. What is the difference between the Bank branche(per 100,000 adults) of Cabo Verde in 2008 and the Bank branche(per 100,000 adults) of Vanuatu in 2010?
Offer a terse response. 5.01. What is the difference between the Bank branche(per 100,000 adults) in Fiji in 2008 and the Bank branche(per 100,000 adults) in Grenada in 2010?
Keep it short and to the point. -21.37. What is the difference between the Bank branche(per 100,000 adults) in Fiji in 2008 and the Bank branche(per 100,000 adults) in Vanuatu in 2010?
Keep it short and to the point. -8.97. What is the difference between the Bank branche(per 100,000 adults) in Grenada in 2008 and the Bank branche(per 100,000 adults) in Vanuatu in 2010?
Offer a very short reply. 12.98. What is the difference between the Bank branche(per 100,000 adults) of Cabo Verde in 2008 and the Bank branche(per 100,000 adults) of Fiji in 2011?
Your response must be concise. 14.69. What is the difference between the Bank branche(per 100,000 adults) in Cabo Verde in 2008 and the Bank branche(per 100,000 adults) in Grenada in 2011?
Make the answer very short. -8.44. What is the difference between the Bank branche(per 100,000 adults) in Cabo Verde in 2008 and the Bank branche(per 100,000 adults) in Vanuatu in 2011?
Offer a very short reply. 4.94. What is the difference between the Bank branche(per 100,000 adults) in Fiji in 2008 and the Bank branche(per 100,000 adults) in Grenada in 2011?
Keep it short and to the point. -22.42. What is the difference between the Bank branche(per 100,000 adults) in Fiji in 2008 and the Bank branche(per 100,000 adults) in Vanuatu in 2011?
Ensure brevity in your answer.  -9.04. What is the difference between the Bank branche(per 100,000 adults) in Grenada in 2008 and the Bank branche(per 100,000 adults) in Vanuatu in 2011?
Your answer should be compact. 12.91. What is the difference between the Bank branche(per 100,000 adults) in Cabo Verde in 2009 and the Bank branche(per 100,000 adults) in Fiji in 2010?
Give a very brief answer. 17.05. What is the difference between the Bank branche(per 100,000 adults) in Cabo Verde in 2009 and the Bank branche(per 100,000 adults) in Grenada in 2010?
Your response must be concise. -4.77. What is the difference between the Bank branche(per 100,000 adults) in Cabo Verde in 2009 and the Bank branche(per 100,000 adults) in Vanuatu in 2010?
Make the answer very short. 7.64. What is the difference between the Bank branche(per 100,000 adults) in Fiji in 2009 and the Bank branche(per 100,000 adults) in Grenada in 2010?
Provide a succinct answer. -21.68. What is the difference between the Bank branche(per 100,000 adults) in Fiji in 2009 and the Bank branche(per 100,000 adults) in Vanuatu in 2010?
Provide a succinct answer. -9.28. What is the difference between the Bank branche(per 100,000 adults) of Grenada in 2009 and the Bank branche(per 100,000 adults) of Vanuatu in 2010?
Ensure brevity in your answer.  12.68. What is the difference between the Bank branche(per 100,000 adults) in Cabo Verde in 2009 and the Bank branche(per 100,000 adults) in Fiji in 2011?
Ensure brevity in your answer.  17.32. What is the difference between the Bank branche(per 100,000 adults) of Cabo Verde in 2009 and the Bank branche(per 100,000 adults) of Grenada in 2011?
Keep it short and to the point. -5.82. What is the difference between the Bank branche(per 100,000 adults) in Cabo Verde in 2009 and the Bank branche(per 100,000 adults) in Vanuatu in 2011?
Provide a succinct answer. 7.56. What is the difference between the Bank branche(per 100,000 adults) in Fiji in 2009 and the Bank branche(per 100,000 adults) in Grenada in 2011?
Make the answer very short. -22.73. What is the difference between the Bank branche(per 100,000 adults) of Fiji in 2009 and the Bank branche(per 100,000 adults) of Vanuatu in 2011?
Give a very brief answer. -9.35. What is the difference between the Bank branche(per 100,000 adults) of Grenada in 2009 and the Bank branche(per 100,000 adults) of Vanuatu in 2011?
Provide a short and direct response. 12.61. What is the difference between the Bank branche(per 100,000 adults) in Cabo Verde in 2010 and the Bank branche(per 100,000 adults) in Fiji in 2011?
Your answer should be compact. 20.43. What is the difference between the Bank branche(per 100,000 adults) of Cabo Verde in 2010 and the Bank branche(per 100,000 adults) of Grenada in 2011?
Offer a very short reply. -2.71. What is the difference between the Bank branche(per 100,000 adults) in Cabo Verde in 2010 and the Bank branche(per 100,000 adults) in Vanuatu in 2011?
Give a very brief answer. 10.67. What is the difference between the Bank branche(per 100,000 adults) in Fiji in 2010 and the Bank branche(per 100,000 adults) in Grenada in 2011?
Your response must be concise. -22.86. What is the difference between the Bank branche(per 100,000 adults) in Fiji in 2010 and the Bank branche(per 100,000 adults) in Vanuatu in 2011?
Ensure brevity in your answer.  -9.48. What is the difference between the Bank branche(per 100,000 adults) of Grenada in 2010 and the Bank branche(per 100,000 adults) of Vanuatu in 2011?
Your response must be concise. 12.33. What is the average Bank branche(per 100,000 adults) of Cabo Verde per year?
Your answer should be compact. 23.25. What is the average Bank branche(per 100,000 adults) in Fiji per year?
Make the answer very short. 10.69. What is the average Bank branche(per 100,000 adults) of Grenada per year?
Your response must be concise. 34.32. What is the average Bank branche(per 100,000 adults) in Vanuatu per year?
Provide a short and direct response. 19.99. In the year 2004, what is the difference between the Bank branche(per 100,000 adults) of Cabo Verde and Bank branche(per 100,000 adults) of Fiji?
Make the answer very short. 6.4. In the year 2004, what is the difference between the Bank branche(per 100,000 adults) in Cabo Verde and Bank branche(per 100,000 adults) in Grenada?
Provide a short and direct response. -22.42. In the year 2004, what is the difference between the Bank branche(per 100,000 adults) of Cabo Verde and Bank branche(per 100,000 adults) of Vanuatu?
Provide a succinct answer. -3.94. In the year 2004, what is the difference between the Bank branche(per 100,000 adults) in Fiji and Bank branche(per 100,000 adults) in Grenada?
Ensure brevity in your answer.  -28.82. In the year 2004, what is the difference between the Bank branche(per 100,000 adults) in Fiji and Bank branche(per 100,000 adults) in Vanuatu?
Provide a short and direct response. -10.34. In the year 2004, what is the difference between the Bank branche(per 100,000 adults) in Grenada and Bank branche(per 100,000 adults) in Vanuatu?
Make the answer very short. 18.49. In the year 2005, what is the difference between the Bank branche(per 100,000 adults) in Cabo Verde and Bank branche(per 100,000 adults) in Fiji?
Ensure brevity in your answer.  6.26. In the year 2005, what is the difference between the Bank branche(per 100,000 adults) of Cabo Verde and Bank branche(per 100,000 adults) of Grenada?
Offer a terse response. -18.81. In the year 2005, what is the difference between the Bank branche(per 100,000 adults) in Cabo Verde and Bank branche(per 100,000 adults) in Vanuatu?
Give a very brief answer. -3.1. In the year 2005, what is the difference between the Bank branche(per 100,000 adults) of Fiji and Bank branche(per 100,000 adults) of Grenada?
Provide a short and direct response. -25.07. In the year 2005, what is the difference between the Bank branche(per 100,000 adults) in Fiji and Bank branche(per 100,000 adults) in Vanuatu?
Provide a succinct answer. -9.36. In the year 2005, what is the difference between the Bank branche(per 100,000 adults) of Grenada and Bank branche(per 100,000 adults) of Vanuatu?
Your answer should be compact. 15.71. In the year 2006, what is the difference between the Bank branche(per 100,000 adults) of Cabo Verde and Bank branche(per 100,000 adults) of Fiji?
Offer a terse response. 7.27. In the year 2006, what is the difference between the Bank branche(per 100,000 adults) of Cabo Verde and Bank branche(per 100,000 adults) of Grenada?
Make the answer very short. -16.45. In the year 2006, what is the difference between the Bank branche(per 100,000 adults) of Cabo Verde and Bank branche(per 100,000 adults) of Vanuatu?
Offer a very short reply. -1.41. In the year 2006, what is the difference between the Bank branche(per 100,000 adults) of Fiji and Bank branche(per 100,000 adults) of Grenada?
Your answer should be compact. -23.72. In the year 2006, what is the difference between the Bank branche(per 100,000 adults) in Fiji and Bank branche(per 100,000 adults) in Vanuatu?
Provide a short and direct response. -8.68. In the year 2006, what is the difference between the Bank branche(per 100,000 adults) of Grenada and Bank branche(per 100,000 adults) of Vanuatu?
Make the answer very short. 15.04. In the year 2007, what is the difference between the Bank branche(per 100,000 adults) in Cabo Verde and Bank branche(per 100,000 adults) in Fiji?
Your response must be concise. 9.71. In the year 2007, what is the difference between the Bank branche(per 100,000 adults) in Cabo Verde and Bank branche(per 100,000 adults) in Grenada?
Give a very brief answer. -12.91. In the year 2007, what is the difference between the Bank branche(per 100,000 adults) in Cabo Verde and Bank branche(per 100,000 adults) in Vanuatu?
Your answer should be very brief. 0.04. In the year 2007, what is the difference between the Bank branche(per 100,000 adults) of Fiji and Bank branche(per 100,000 adults) of Grenada?
Keep it short and to the point. -22.63. In the year 2007, what is the difference between the Bank branche(per 100,000 adults) in Fiji and Bank branche(per 100,000 adults) in Vanuatu?
Make the answer very short. -9.67. In the year 2007, what is the difference between the Bank branche(per 100,000 adults) of Grenada and Bank branche(per 100,000 adults) of Vanuatu?
Provide a short and direct response. 12.96. In the year 2008, what is the difference between the Bank branche(per 100,000 adults) of Cabo Verde and Bank branche(per 100,000 adults) of Fiji?
Offer a terse response. 13.98. In the year 2008, what is the difference between the Bank branche(per 100,000 adults) of Cabo Verde and Bank branche(per 100,000 adults) of Grenada?
Ensure brevity in your answer.  -7.97. In the year 2008, what is the difference between the Bank branche(per 100,000 adults) of Cabo Verde and Bank branche(per 100,000 adults) of Vanuatu?
Keep it short and to the point. 5.25. In the year 2008, what is the difference between the Bank branche(per 100,000 adults) of Fiji and Bank branche(per 100,000 adults) of Grenada?
Your answer should be compact. -21.95. In the year 2008, what is the difference between the Bank branche(per 100,000 adults) of Fiji and Bank branche(per 100,000 adults) of Vanuatu?
Offer a very short reply. -8.73. In the year 2008, what is the difference between the Bank branche(per 100,000 adults) of Grenada and Bank branche(per 100,000 adults) of Vanuatu?
Your answer should be very brief. 13.21. In the year 2009, what is the difference between the Bank branche(per 100,000 adults) in Cabo Verde and Bank branche(per 100,000 adults) in Fiji?
Provide a short and direct response. 16.92. In the year 2009, what is the difference between the Bank branche(per 100,000 adults) of Cabo Verde and Bank branche(per 100,000 adults) of Grenada?
Ensure brevity in your answer.  -5.04. In the year 2009, what is the difference between the Bank branche(per 100,000 adults) in Cabo Verde and Bank branche(per 100,000 adults) in Vanuatu?
Keep it short and to the point. 8.44. In the year 2009, what is the difference between the Bank branche(per 100,000 adults) in Fiji and Bank branche(per 100,000 adults) in Grenada?
Offer a terse response. -21.96. In the year 2009, what is the difference between the Bank branche(per 100,000 adults) of Fiji and Bank branche(per 100,000 adults) of Vanuatu?
Ensure brevity in your answer.  -8.47. In the year 2009, what is the difference between the Bank branche(per 100,000 adults) of Grenada and Bank branche(per 100,000 adults) of Vanuatu?
Ensure brevity in your answer.  13.49. In the year 2010, what is the difference between the Bank branche(per 100,000 adults) of Cabo Verde and Bank branche(per 100,000 adults) of Fiji?
Your answer should be very brief. 20.15. In the year 2010, what is the difference between the Bank branche(per 100,000 adults) in Cabo Verde and Bank branche(per 100,000 adults) in Grenada?
Keep it short and to the point. -1.66. In the year 2010, what is the difference between the Bank branche(per 100,000 adults) in Cabo Verde and Bank branche(per 100,000 adults) in Vanuatu?
Provide a short and direct response. 10.75. In the year 2010, what is the difference between the Bank branche(per 100,000 adults) of Fiji and Bank branche(per 100,000 adults) of Grenada?
Your response must be concise. -21.81. In the year 2010, what is the difference between the Bank branche(per 100,000 adults) of Fiji and Bank branche(per 100,000 adults) of Vanuatu?
Ensure brevity in your answer.  -9.41. In the year 2010, what is the difference between the Bank branche(per 100,000 adults) in Grenada and Bank branche(per 100,000 adults) in Vanuatu?
Offer a terse response. 12.4. In the year 2011, what is the difference between the Bank branche(per 100,000 adults) in Cabo Verde and Bank branche(per 100,000 adults) in Fiji?
Make the answer very short. 19.84. In the year 2011, what is the difference between the Bank branche(per 100,000 adults) in Cabo Verde and Bank branche(per 100,000 adults) in Grenada?
Make the answer very short. -3.29. In the year 2011, what is the difference between the Bank branche(per 100,000 adults) of Cabo Verde and Bank branche(per 100,000 adults) of Vanuatu?
Keep it short and to the point. 10.09. In the year 2011, what is the difference between the Bank branche(per 100,000 adults) in Fiji and Bank branche(per 100,000 adults) in Grenada?
Make the answer very short. -23.13. In the year 2011, what is the difference between the Bank branche(per 100,000 adults) of Fiji and Bank branche(per 100,000 adults) of Vanuatu?
Keep it short and to the point. -9.75. In the year 2011, what is the difference between the Bank branche(per 100,000 adults) in Grenada and Bank branche(per 100,000 adults) in Vanuatu?
Offer a very short reply. 13.38. What is the ratio of the Bank branche(per 100,000 adults) in Cabo Verde in 2004 to that in 2005?
Offer a very short reply. 0.98. What is the ratio of the Bank branche(per 100,000 adults) of Fiji in 2004 to that in 2005?
Provide a succinct answer. 0.96. What is the ratio of the Bank branche(per 100,000 adults) in Grenada in 2004 to that in 2005?
Your answer should be compact. 1.1. What is the ratio of the Bank branche(per 100,000 adults) of Vanuatu in 2004 to that in 2005?
Give a very brief answer. 1.03. What is the ratio of the Bank branche(per 100,000 adults) of Cabo Verde in 2004 to that in 2006?
Ensure brevity in your answer.  0.88. What is the ratio of the Bank branche(per 100,000 adults) of Fiji in 2004 to that in 2006?
Provide a succinct answer. 0.88. What is the ratio of the Bank branche(per 100,000 adults) in Grenada in 2004 to that in 2006?
Give a very brief answer. 1.11. What is the ratio of the Bank branche(per 100,000 adults) in Vanuatu in 2004 to that in 2006?
Your response must be concise. 1.02. What is the ratio of the Bank branche(per 100,000 adults) of Cabo Verde in 2004 to that in 2007?
Your answer should be compact. 0.75. What is the ratio of the Bank branche(per 100,000 adults) of Fiji in 2004 to that in 2007?
Your response must be concise. 0.82. What is the ratio of the Bank branche(per 100,000 adults) of Grenada in 2004 to that in 2007?
Offer a very short reply. 1.12. What is the ratio of the Bank branche(per 100,000 adults) of Vanuatu in 2004 to that in 2007?
Your answer should be compact. 0.94. What is the ratio of the Bank branche(per 100,000 adults) in Cabo Verde in 2004 to that in 2008?
Offer a very short reply. 0.61. What is the ratio of the Bank branche(per 100,000 adults) of Fiji in 2004 to that in 2008?
Give a very brief answer. 0.8. What is the ratio of the Bank branche(per 100,000 adults) in Grenada in 2004 to that in 2008?
Provide a succinct answer. 1.14. What is the ratio of the Bank branche(per 100,000 adults) of Vanuatu in 2004 to that in 2008?
Your response must be concise. 0.96. What is the ratio of the Bank branche(per 100,000 adults) of Cabo Verde in 2004 to that in 2009?
Give a very brief answer. 0.56. What is the ratio of the Bank branche(per 100,000 adults) of Fiji in 2004 to that in 2009?
Your answer should be very brief. 0.82. What is the ratio of the Bank branche(per 100,000 adults) in Grenada in 2004 to that in 2009?
Your response must be concise. 1.15. What is the ratio of the Bank branche(per 100,000 adults) in Cabo Verde in 2004 to that in 2010?
Offer a very short reply. 0.5. What is the ratio of the Bank branche(per 100,000 adults) of Fiji in 2004 to that in 2010?
Your response must be concise. 0.83. What is the ratio of the Bank branche(per 100,000 adults) of Grenada in 2004 to that in 2010?
Give a very brief answer. 1.16. What is the ratio of the Bank branche(per 100,000 adults) in Vanuatu in 2004 to that in 2010?
Offer a terse response. 0.95. What is the ratio of the Bank branche(per 100,000 adults) in Cabo Verde in 2004 to that in 2011?
Give a very brief answer. 0.51. What is the ratio of the Bank branche(per 100,000 adults) in Fiji in 2004 to that in 2011?
Your answer should be compact. 0.85. What is the ratio of the Bank branche(per 100,000 adults) of Grenada in 2004 to that in 2011?
Ensure brevity in your answer.  1.12. What is the ratio of the Bank branche(per 100,000 adults) in Vanuatu in 2004 to that in 2011?
Provide a short and direct response. 0.95. What is the ratio of the Bank branche(per 100,000 adults) of Cabo Verde in 2005 to that in 2006?
Offer a very short reply. 0.89. What is the ratio of the Bank branche(per 100,000 adults) of Fiji in 2005 to that in 2006?
Offer a very short reply. 0.92. What is the ratio of the Bank branche(per 100,000 adults) in Grenada in 2005 to that in 2006?
Your answer should be compact. 1.01. What is the ratio of the Bank branche(per 100,000 adults) of Cabo Verde in 2005 to that in 2007?
Offer a very short reply. 0.76. What is the ratio of the Bank branche(per 100,000 adults) in Fiji in 2005 to that in 2007?
Keep it short and to the point. 0.86. What is the ratio of the Bank branche(per 100,000 adults) of Grenada in 2005 to that in 2007?
Offer a very short reply. 1.03. What is the ratio of the Bank branche(per 100,000 adults) in Cabo Verde in 2005 to that in 2008?
Offer a terse response. 0.62. What is the ratio of the Bank branche(per 100,000 adults) of Fiji in 2005 to that in 2008?
Offer a terse response. 0.83. What is the ratio of the Bank branche(per 100,000 adults) of Grenada in 2005 to that in 2008?
Ensure brevity in your answer.  1.04. What is the ratio of the Bank branche(per 100,000 adults) in Vanuatu in 2005 to that in 2008?
Your response must be concise. 0.94. What is the ratio of the Bank branche(per 100,000 adults) of Cabo Verde in 2005 to that in 2009?
Provide a succinct answer. 0.56. What is the ratio of the Bank branche(per 100,000 adults) in Fiji in 2005 to that in 2009?
Give a very brief answer. 0.86. What is the ratio of the Bank branche(per 100,000 adults) in Grenada in 2005 to that in 2009?
Your answer should be very brief. 1.04. What is the ratio of the Bank branche(per 100,000 adults) of Vanuatu in 2005 to that in 2009?
Your answer should be compact. 0.96. What is the ratio of the Bank branche(per 100,000 adults) in Cabo Verde in 2005 to that in 2010?
Provide a short and direct response. 0.51. What is the ratio of the Bank branche(per 100,000 adults) in Fiji in 2005 to that in 2010?
Give a very brief answer. 0.87. What is the ratio of the Bank branche(per 100,000 adults) in Grenada in 2005 to that in 2010?
Make the answer very short. 1.05. What is the ratio of the Bank branche(per 100,000 adults) of Vanuatu in 2005 to that in 2010?
Provide a short and direct response. 0.92. What is the ratio of the Bank branche(per 100,000 adults) in Cabo Verde in 2005 to that in 2011?
Your answer should be compact. 0.52. What is the ratio of the Bank branche(per 100,000 adults) of Fiji in 2005 to that in 2011?
Ensure brevity in your answer.  0.89. What is the ratio of the Bank branche(per 100,000 adults) of Grenada in 2005 to that in 2011?
Offer a terse response. 1.02. What is the ratio of the Bank branche(per 100,000 adults) of Vanuatu in 2005 to that in 2011?
Your answer should be compact. 0.92. What is the ratio of the Bank branche(per 100,000 adults) in Cabo Verde in 2006 to that in 2007?
Offer a very short reply. 0.85. What is the ratio of the Bank branche(per 100,000 adults) in Fiji in 2006 to that in 2007?
Your answer should be very brief. 0.94. What is the ratio of the Bank branche(per 100,000 adults) in Grenada in 2006 to that in 2007?
Make the answer very short. 1.01. What is the ratio of the Bank branche(per 100,000 adults) in Vanuatu in 2006 to that in 2007?
Offer a very short reply. 0.92. What is the ratio of the Bank branche(per 100,000 adults) of Cabo Verde in 2006 to that in 2008?
Offer a very short reply. 0.7. What is the ratio of the Bank branche(per 100,000 adults) of Fiji in 2006 to that in 2008?
Offer a terse response. 0.91. What is the ratio of the Bank branche(per 100,000 adults) of Grenada in 2006 to that in 2008?
Provide a succinct answer. 1.02. What is the ratio of the Bank branche(per 100,000 adults) of Vanuatu in 2006 to that in 2008?
Keep it short and to the point. 0.95. What is the ratio of the Bank branche(per 100,000 adults) in Cabo Verde in 2006 to that in 2009?
Give a very brief answer. 0.63. What is the ratio of the Bank branche(per 100,000 adults) of Fiji in 2006 to that in 2009?
Give a very brief answer. 0.93. What is the ratio of the Bank branche(per 100,000 adults) of Grenada in 2006 to that in 2009?
Ensure brevity in your answer.  1.03. What is the ratio of the Bank branche(per 100,000 adults) in Vanuatu in 2006 to that in 2009?
Offer a very short reply. 0.97. What is the ratio of the Bank branche(per 100,000 adults) in Cabo Verde in 2006 to that in 2010?
Ensure brevity in your answer.  0.57. What is the ratio of the Bank branche(per 100,000 adults) in Fiji in 2006 to that in 2010?
Offer a terse response. 0.95. What is the ratio of the Bank branche(per 100,000 adults) of Grenada in 2006 to that in 2010?
Your answer should be very brief. 1.04. What is the ratio of the Bank branche(per 100,000 adults) of Vanuatu in 2006 to that in 2010?
Offer a terse response. 0.93. What is the ratio of the Bank branche(per 100,000 adults) in Cabo Verde in 2006 to that in 2011?
Offer a very short reply. 0.58. What is the ratio of the Bank branche(per 100,000 adults) of Fiji in 2006 to that in 2011?
Your response must be concise. 0.97. What is the ratio of the Bank branche(per 100,000 adults) of Grenada in 2006 to that in 2011?
Make the answer very short. 1.01. What is the ratio of the Bank branche(per 100,000 adults) of Vanuatu in 2006 to that in 2011?
Provide a short and direct response. 0.93. What is the ratio of the Bank branche(per 100,000 adults) of Cabo Verde in 2007 to that in 2008?
Ensure brevity in your answer.  0.82. What is the ratio of the Bank branche(per 100,000 adults) in Fiji in 2007 to that in 2008?
Offer a terse response. 0.97. What is the ratio of the Bank branche(per 100,000 adults) of Grenada in 2007 to that in 2008?
Ensure brevity in your answer.  1.01. What is the ratio of the Bank branche(per 100,000 adults) in Cabo Verde in 2007 to that in 2009?
Ensure brevity in your answer.  0.74. What is the ratio of the Bank branche(per 100,000 adults) in Fiji in 2007 to that in 2009?
Keep it short and to the point. 1. What is the ratio of the Bank branche(per 100,000 adults) of Vanuatu in 2007 to that in 2009?
Provide a short and direct response. 1.06. What is the ratio of the Bank branche(per 100,000 adults) of Cabo Verde in 2007 to that in 2010?
Provide a short and direct response. 0.67. What is the ratio of the Bank branche(per 100,000 adults) in Fiji in 2007 to that in 2010?
Keep it short and to the point. 1.01. What is the ratio of the Bank branche(per 100,000 adults) in Grenada in 2007 to that in 2010?
Your answer should be very brief. 1.03. What is the ratio of the Bank branche(per 100,000 adults) in Vanuatu in 2007 to that in 2010?
Provide a succinct answer. 1.02. What is the ratio of the Bank branche(per 100,000 adults) in Cabo Verde in 2007 to that in 2011?
Ensure brevity in your answer.  0.68. What is the ratio of the Bank branche(per 100,000 adults) in Fiji in 2007 to that in 2011?
Make the answer very short. 1.03. What is the ratio of the Bank branche(per 100,000 adults) in Vanuatu in 2007 to that in 2011?
Give a very brief answer. 1.01. What is the ratio of the Bank branche(per 100,000 adults) in Cabo Verde in 2008 to that in 2009?
Make the answer very short. 0.91. What is the ratio of the Bank branche(per 100,000 adults) of Fiji in 2008 to that in 2009?
Your answer should be compact. 1.03. What is the ratio of the Bank branche(per 100,000 adults) in Vanuatu in 2008 to that in 2009?
Offer a very short reply. 1.03. What is the ratio of the Bank branche(per 100,000 adults) in Cabo Verde in 2008 to that in 2010?
Make the answer very short. 0.82. What is the ratio of the Bank branche(per 100,000 adults) of Fiji in 2008 to that in 2010?
Provide a succinct answer. 1.04. What is the ratio of the Bank branche(per 100,000 adults) of Grenada in 2008 to that in 2010?
Offer a very short reply. 1.02. What is the ratio of the Bank branche(per 100,000 adults) of Vanuatu in 2008 to that in 2010?
Your answer should be very brief. 0.99. What is the ratio of the Bank branche(per 100,000 adults) in Cabo Verde in 2008 to that in 2011?
Make the answer very short. 0.83. What is the ratio of the Bank branche(per 100,000 adults) of Fiji in 2008 to that in 2011?
Keep it short and to the point. 1.07. What is the ratio of the Bank branche(per 100,000 adults) of Grenada in 2008 to that in 2011?
Provide a succinct answer. 0.99. What is the ratio of the Bank branche(per 100,000 adults) of Vanuatu in 2008 to that in 2011?
Make the answer very short. 0.98. What is the ratio of the Bank branche(per 100,000 adults) in Cabo Verde in 2009 to that in 2010?
Ensure brevity in your answer.  0.9. What is the ratio of the Bank branche(per 100,000 adults) in Fiji in 2009 to that in 2010?
Provide a short and direct response. 1.01. What is the ratio of the Bank branche(per 100,000 adults) in Grenada in 2009 to that in 2010?
Give a very brief answer. 1.01. What is the ratio of the Bank branche(per 100,000 adults) in Vanuatu in 2009 to that in 2010?
Your response must be concise. 0.96. What is the ratio of the Bank branche(per 100,000 adults) of Cabo Verde in 2009 to that in 2011?
Offer a very short reply. 0.92. What is the ratio of the Bank branche(per 100,000 adults) in Fiji in 2009 to that in 2011?
Your response must be concise. 1.04. What is the ratio of the Bank branche(per 100,000 adults) of Grenada in 2009 to that in 2011?
Offer a terse response. 0.98. What is the ratio of the Bank branche(per 100,000 adults) in Vanuatu in 2009 to that in 2011?
Keep it short and to the point. 0.96. What is the ratio of the Bank branche(per 100,000 adults) of Cabo Verde in 2010 to that in 2011?
Offer a terse response. 1.02. What is the ratio of the Bank branche(per 100,000 adults) in Fiji in 2010 to that in 2011?
Your answer should be compact. 1.03. What is the ratio of the Bank branche(per 100,000 adults) in Grenada in 2010 to that in 2011?
Your answer should be compact. 0.97. What is the ratio of the Bank branche(per 100,000 adults) in Vanuatu in 2010 to that in 2011?
Your response must be concise. 1. What is the difference between the highest and the second highest Bank branche(per 100,000 adults) of Cabo Verde?
Make the answer very short. 0.58. What is the difference between the highest and the second highest Bank branche(per 100,000 adults) in Fiji?
Offer a terse response. 0.31. What is the difference between the highest and the second highest Bank branche(per 100,000 adults) of Grenada?
Give a very brief answer. 3.37. What is the difference between the highest and the second highest Bank branche(per 100,000 adults) in Vanuatu?
Give a very brief answer. 0.28. What is the difference between the highest and the lowest Bank branche(per 100,000 adults) of Cabo Verde?
Make the answer very short. 15.63. What is the difference between the highest and the lowest Bank branche(per 100,000 adults) in Fiji?
Your answer should be very brief. 2.32. What is the difference between the highest and the lowest Bank branche(per 100,000 adults) of Grenada?
Make the answer very short. 5.13. What is the difference between the highest and the lowest Bank branche(per 100,000 adults) in Vanuatu?
Offer a very short reply. 1.9. 